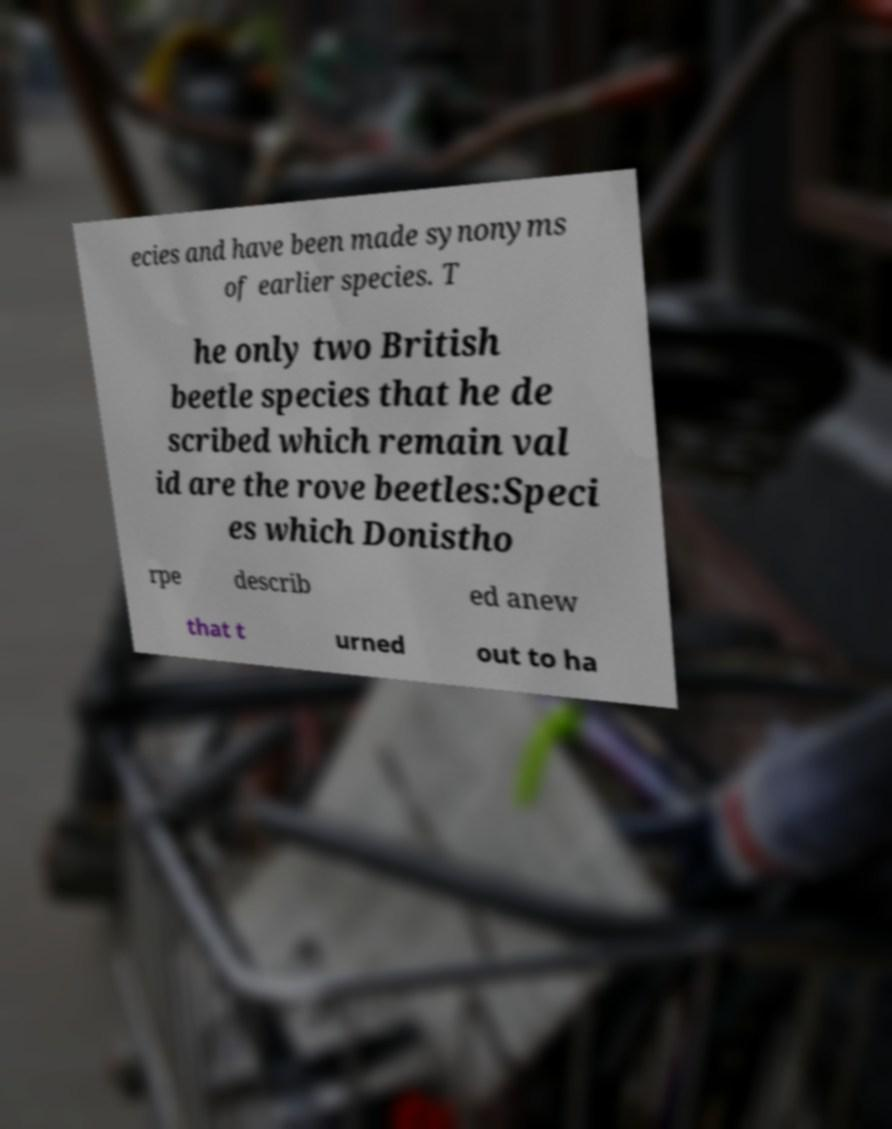For documentation purposes, I need the text within this image transcribed. Could you provide that? ecies and have been made synonyms of earlier species. T he only two British beetle species that he de scribed which remain val id are the rove beetles:Speci es which Donistho rpe describ ed anew that t urned out to ha 